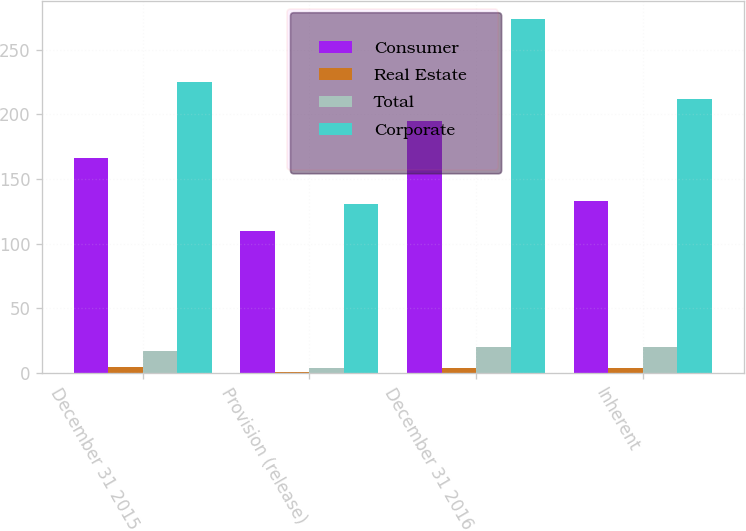<chart> <loc_0><loc_0><loc_500><loc_500><stacked_bar_chart><ecel><fcel>December 31 2015<fcel>Provision (release)<fcel>December 31 2016<fcel>Inherent<nl><fcel>Consumer<fcel>166<fcel>110<fcel>195<fcel>133<nl><fcel>Real Estate<fcel>5<fcel>1<fcel>4<fcel>4<nl><fcel>Total<fcel>17<fcel>4<fcel>20<fcel>20<nl><fcel>Corporate<fcel>225<fcel>131<fcel>274<fcel>212<nl></chart> 